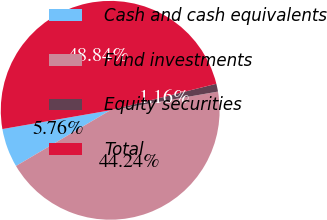Convert chart. <chart><loc_0><loc_0><loc_500><loc_500><pie_chart><fcel>Cash and cash equivalents<fcel>Fund investments<fcel>Equity securities<fcel>Total<nl><fcel>5.76%<fcel>44.24%<fcel>1.16%<fcel>48.84%<nl></chart> 